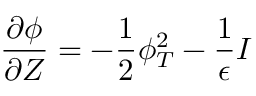Convert formula to latex. <formula><loc_0><loc_0><loc_500><loc_500>\frac { \partial \phi } { \partial Z } = - \frac { 1 } { 2 } \phi _ { T } ^ { 2 } - \frac { 1 } { \epsilon } I</formula> 